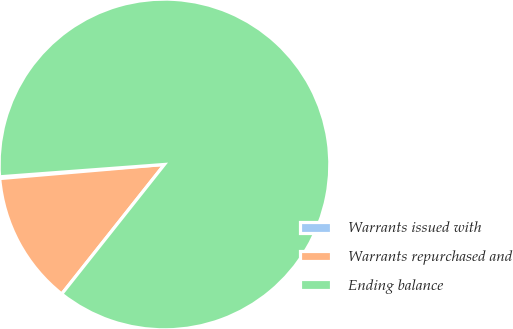Convert chart. <chart><loc_0><loc_0><loc_500><loc_500><pie_chart><fcel>Warrants issued with<fcel>Warrants repurchased and<fcel>Ending balance<nl><fcel>0.17%<fcel>12.97%<fcel>86.86%<nl></chart> 